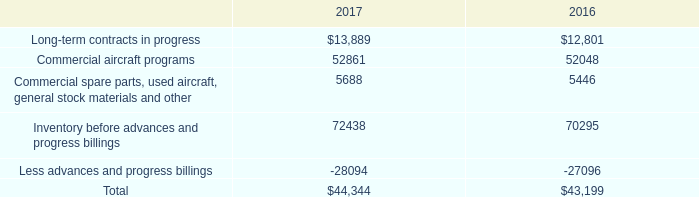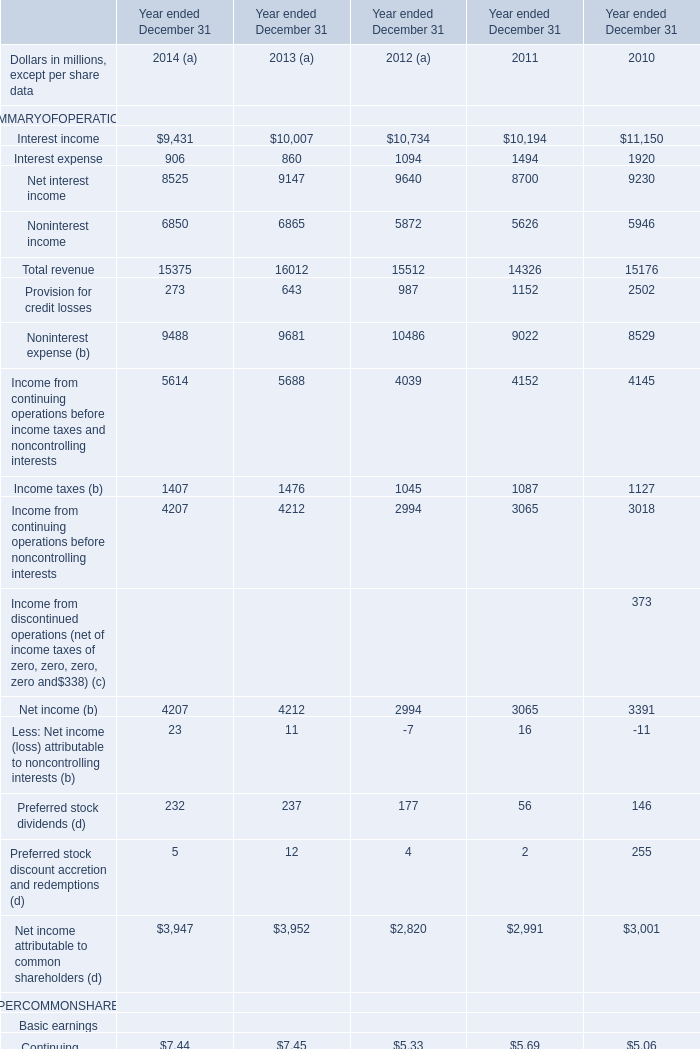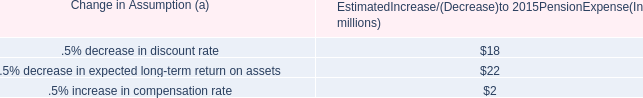what's the percentage increase from the 2014 estimated pretax pension expense with the expense for 2015? 
Computations: (((9 - 7) / 7) * 100)
Answer: 28.57143. 